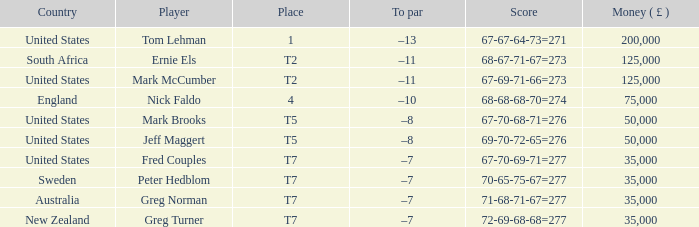What is the highest Money ( £ ), when Player is "Peter Hedblom"? 35000.0. 